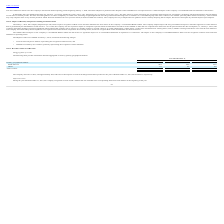From Ringcentral's financial document, What are the respective percentage of subscription revenue derived in the years ended December 2017 and 2018? The document shows two values: 84% and 88%. From the document: "ompany derived over 90%, and approximately 88% and 84% of subscription revenues from RingCentral Office product for the years ended December 31, 2019,..." Also, What are the respective percentage of subscription revenue derived in the years ended December 2018 and 2019? The document shows two values: 88% and over 90%. From the document: "The Company derived over 90%, and approximately 88% and 84% of subscription revenues from RingCentral Office product for the yea The Company derived o..." Also, What are the respective percentage of total revenue earned from North America in 2018 and 2019? The document shows two values: 95% and 93%. From the document: "North America 93% 95% 96% North America 93% 95% 96%..." Also, can you calculate: What is the change in percentage of total revenue earned in North America between 2017 and 2018? Based on the calculation: 95-96, the result is -1 (percentage). This is based on the information: "North America 93% 95% 96% North America 93% 95% 96%..." The key data points involved are: 95, 96. Also, can you calculate: What is the change in percentage of total revenue earned in North America between 2018 and 2019? Based on the calculation: 93-95, the result is -2 (percentage). This is based on the information: "North America 93% 95% 96% North America 93% 95% 96%..." The key data points involved are: 93, 95. Also, can you calculate: What is the average percentage of revenue earned in North America between 2017 to 2019? To answer this question, I need to perform calculations using the financial data. The calculation is: (93 + 95 +96)/3 , which equals 94.67 (percentage). This is based on the information: "North America 93% 95% 96% North America 93% 95% 96% North America 93% 95% 96%..." The key data points involved are: 93, 95, 96. 